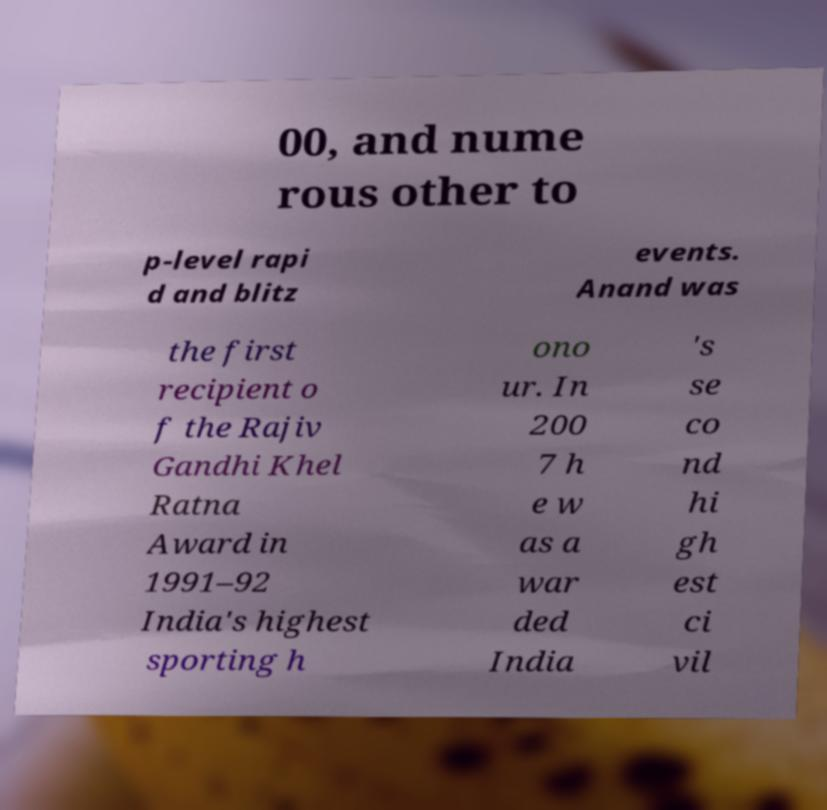Could you assist in decoding the text presented in this image and type it out clearly? 00, and nume rous other to p-level rapi d and blitz events. Anand was the first recipient o f the Rajiv Gandhi Khel Ratna Award in 1991–92 India's highest sporting h ono ur. In 200 7 h e w as a war ded India 's se co nd hi gh est ci vil 